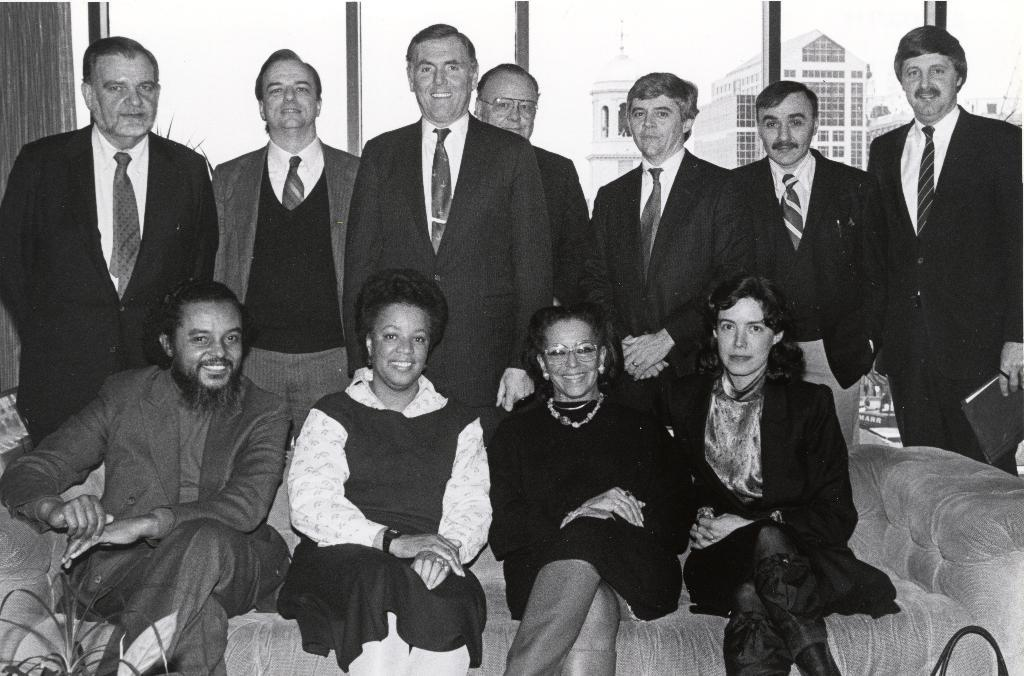How many people are sitting on the couch in the image? There are four people sitting on the couch in the image. What is the facial expression of the people sitting on the couch? The people sitting on the couch are smiling. Can you describe the people standing in the image? There is a group of people standing, and they are also smiling. What can be seen in the background of the image? There is a window, buildings, and the sky visible in the background. What type of writer is visible in the image? There is no writer present in the image. Can you tell me how many bubbles are floating near the standing people? There are no bubbles visible in the image. 